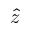<formula> <loc_0><loc_0><loc_500><loc_500>\hat { z }</formula> 